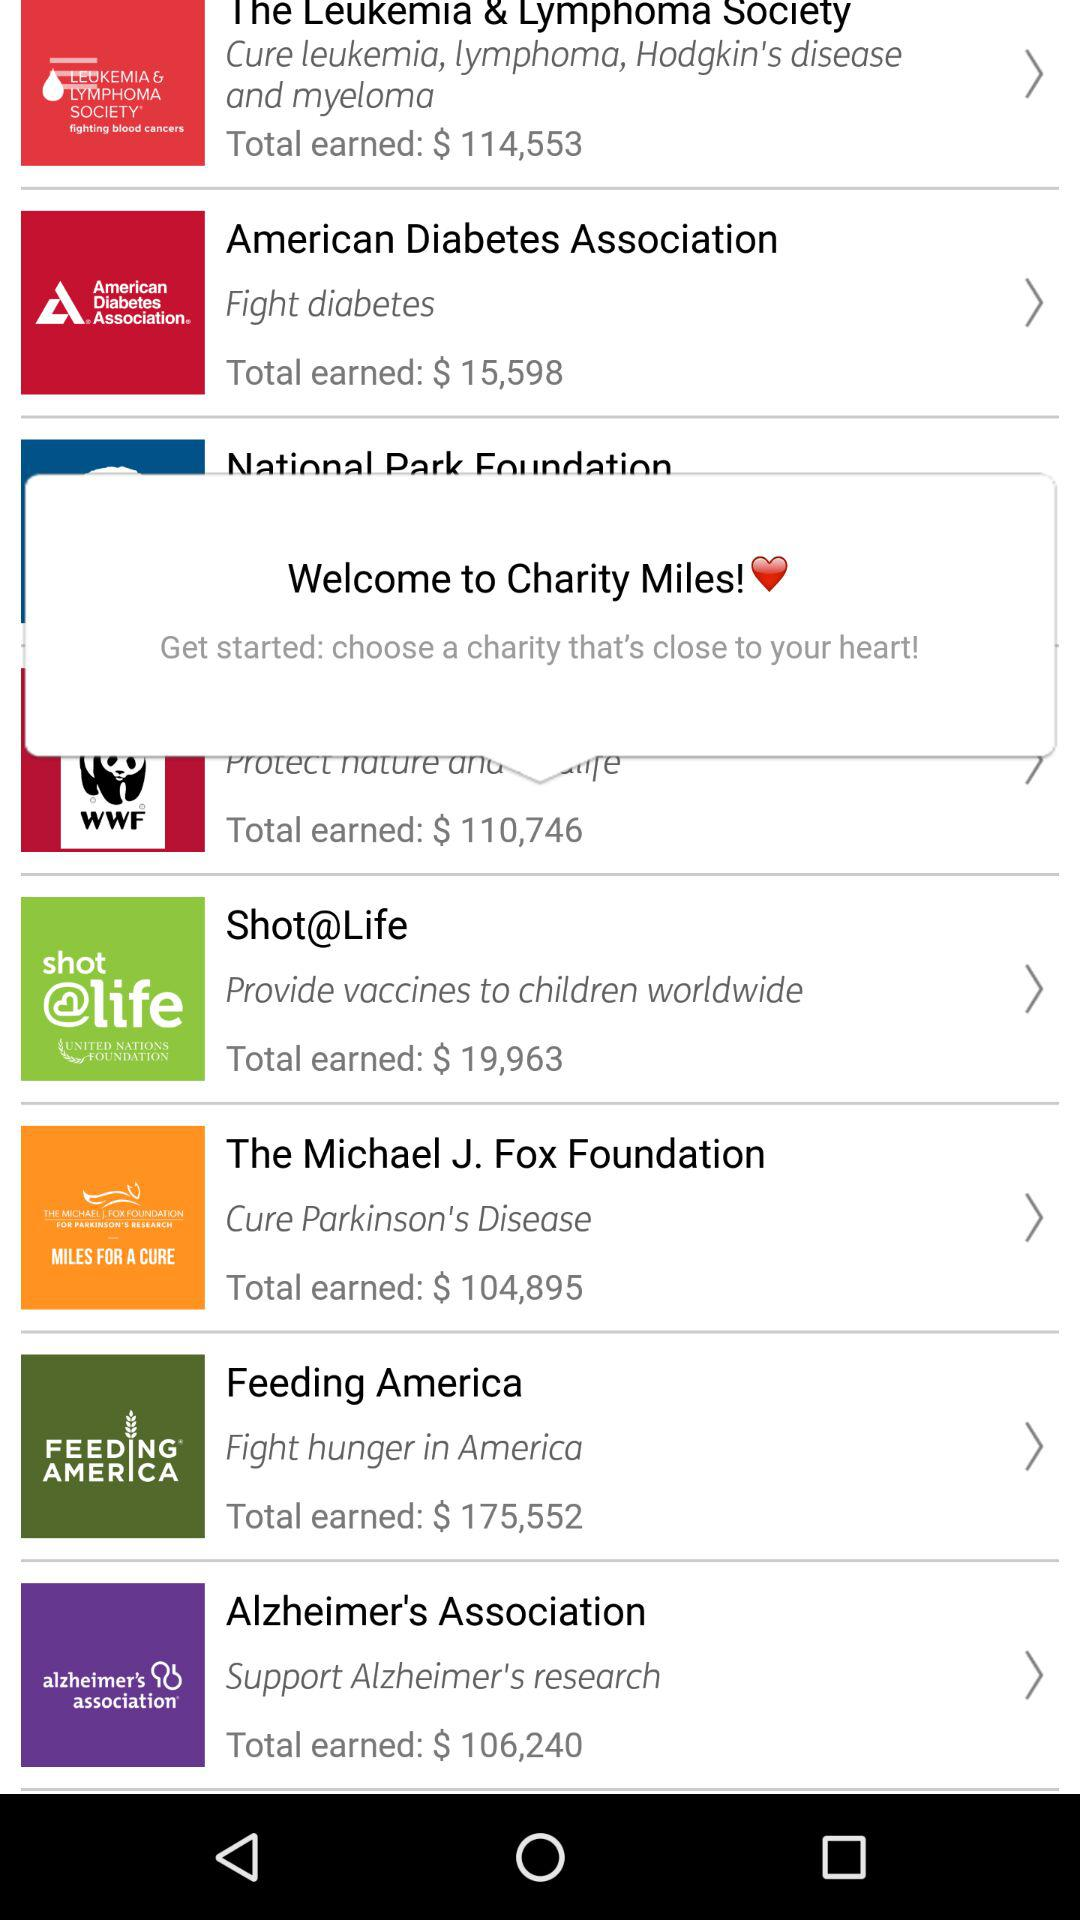What is the total amount earned in $ by "Feeding America"? The total amount earned in dollars is 175,552. 